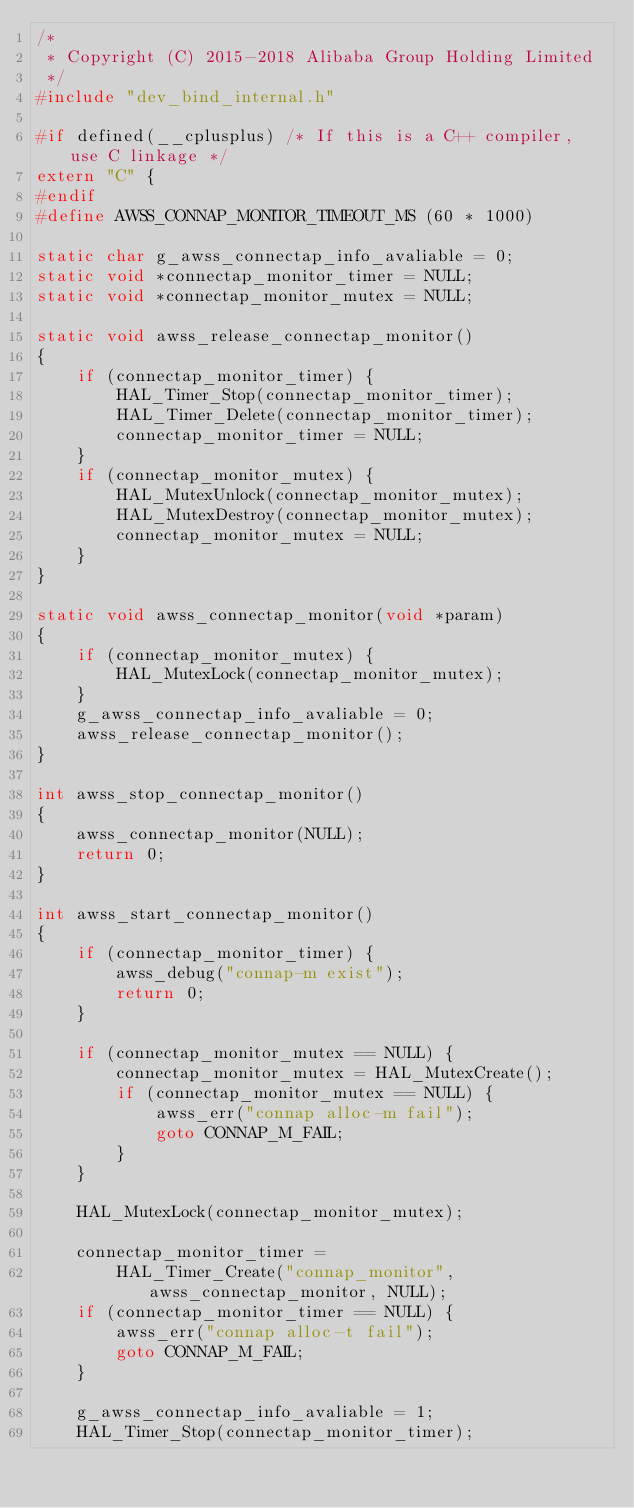<code> <loc_0><loc_0><loc_500><loc_500><_C_>/*
 * Copyright (C) 2015-2018 Alibaba Group Holding Limited
 */
#include "dev_bind_internal.h"

#if defined(__cplusplus) /* If this is a C++ compiler, use C linkage */
extern "C" {
#endif
#define AWSS_CONNAP_MONITOR_TIMEOUT_MS (60 * 1000)

static char g_awss_connectap_info_avaliable = 0;
static void *connectap_monitor_timer = NULL;
static void *connectap_monitor_mutex = NULL;

static void awss_release_connectap_monitor()
{
    if (connectap_monitor_timer) {
        HAL_Timer_Stop(connectap_monitor_timer);
        HAL_Timer_Delete(connectap_monitor_timer);
        connectap_monitor_timer = NULL;
    }
    if (connectap_monitor_mutex) {
        HAL_MutexUnlock(connectap_monitor_mutex);
        HAL_MutexDestroy(connectap_monitor_mutex);
        connectap_monitor_mutex = NULL;
    }
}

static void awss_connectap_monitor(void *param)
{
    if (connectap_monitor_mutex) {
        HAL_MutexLock(connectap_monitor_mutex);
    }
    g_awss_connectap_info_avaliable = 0;
    awss_release_connectap_monitor();
}

int awss_stop_connectap_monitor()
{
    awss_connectap_monitor(NULL);
    return 0;
}

int awss_start_connectap_monitor()
{
    if (connectap_monitor_timer) {
        awss_debug("connap-m exist");
        return 0;
    }

    if (connectap_monitor_mutex == NULL) {
        connectap_monitor_mutex = HAL_MutexCreate();
        if (connectap_monitor_mutex == NULL) {
            awss_err("connap alloc-m fail");
            goto CONNAP_M_FAIL;
        }
    }

    HAL_MutexLock(connectap_monitor_mutex);

    connectap_monitor_timer =
        HAL_Timer_Create("connap_monitor", awss_connectap_monitor, NULL);
    if (connectap_monitor_timer == NULL) {
        awss_err("connap alloc-t fail");
        goto CONNAP_M_FAIL;
    }

    g_awss_connectap_info_avaliable = 1;
    HAL_Timer_Stop(connectap_monitor_timer);</code> 